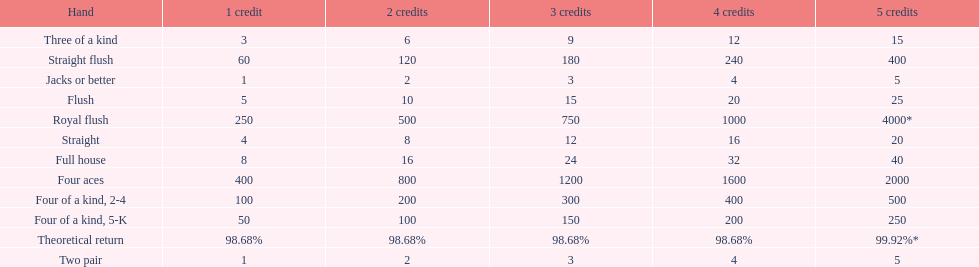At most, what could a person earn for having a full house? 40. 